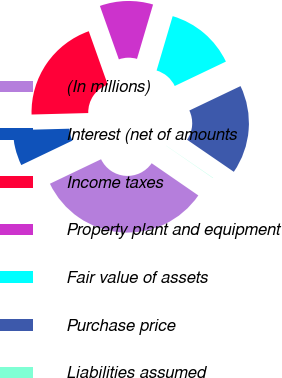<chart> <loc_0><loc_0><loc_500><loc_500><pie_chart><fcel>(In millions)<fcel>Interest (net of amounts<fcel>Income taxes<fcel>Property plant and equipment<fcel>Fair value of assets<fcel>Purchase price<fcel>Liabilities assumed<nl><fcel>33.29%<fcel>6.69%<fcel>19.99%<fcel>10.01%<fcel>13.34%<fcel>16.66%<fcel>0.04%<nl></chart> 